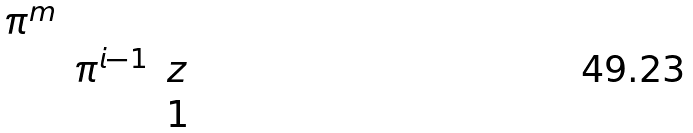<formula> <loc_0><loc_0><loc_500><loc_500>\begin{matrix} \pi ^ { m } & & \\ & \pi ^ { i - 1 } & z \\ & & 1 \end{matrix}</formula> 